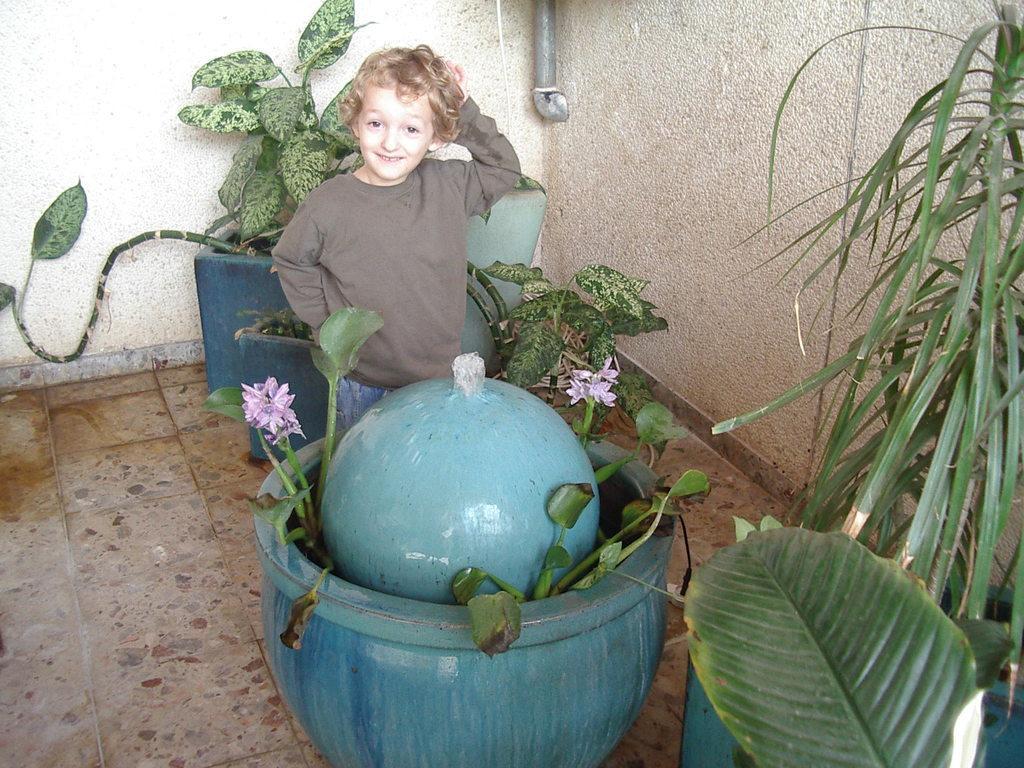Describe this image in one or two sentences. In the center of this picture we can see a kid wearing t-shirt, smiling and standing on the floor and we can see the potted plants, flowers and a ball like object is placed in the pot. In the background we can see the wall and a metal object. 